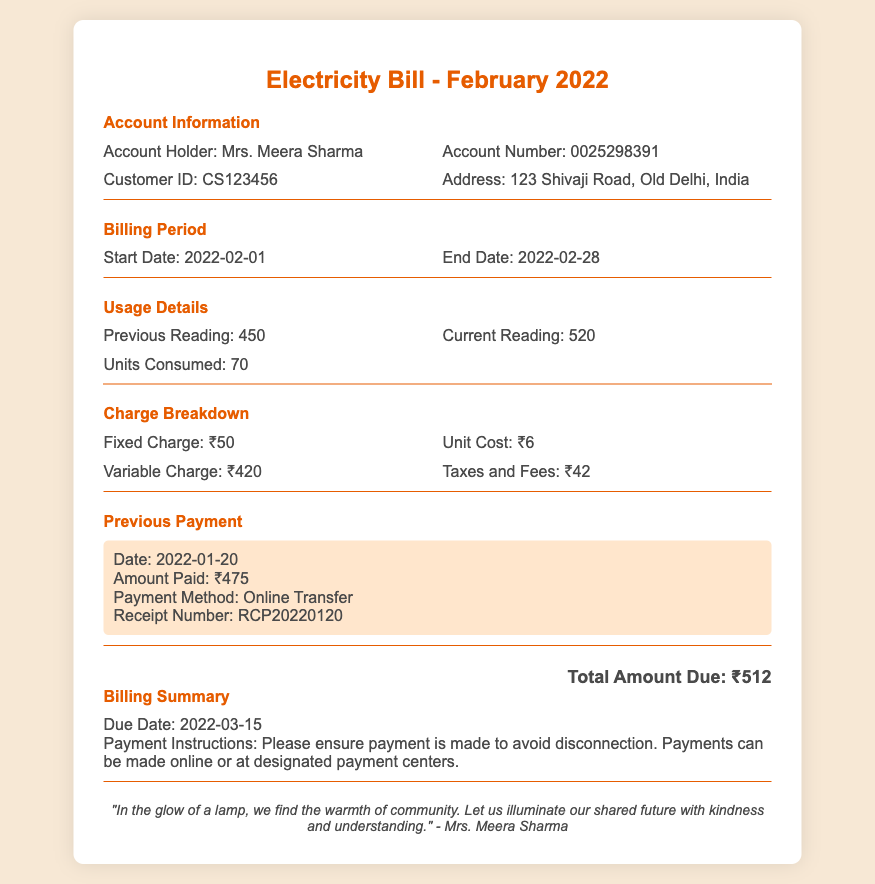What is the account holder's name? The document states the account holder's name is Mrs. Meera Sharma.
Answer: Mrs. Meera Sharma What is the account number? The account number provided in the document is 0025298391.
Answer: 0025298391 What is the total amount due? The total amount due at the end of the billing statement is ₹512.
Answer: ₹512 How many units were consumed? Units consumed are listed in the usage details, which show a total of 70 units.
Answer: 70 What is the fixed charge? The charge breakdown lists the fixed charge as ₹50.
Answer: ₹50 What is the due date for the payment? The billing summary specifies the due date as 2022-03-15.
Answer: 2022-03-15 What payment method was used for the previous payment? The payment history indicates that the previous payment was made via Online Transfer.
Answer: Online Transfer How much was the variable charge? According to the charge breakdown, the variable charge is ₹420.
Answer: ₹420 What is the customer ID? The document shows the customer ID as CS123456.
Answer: CS123456 